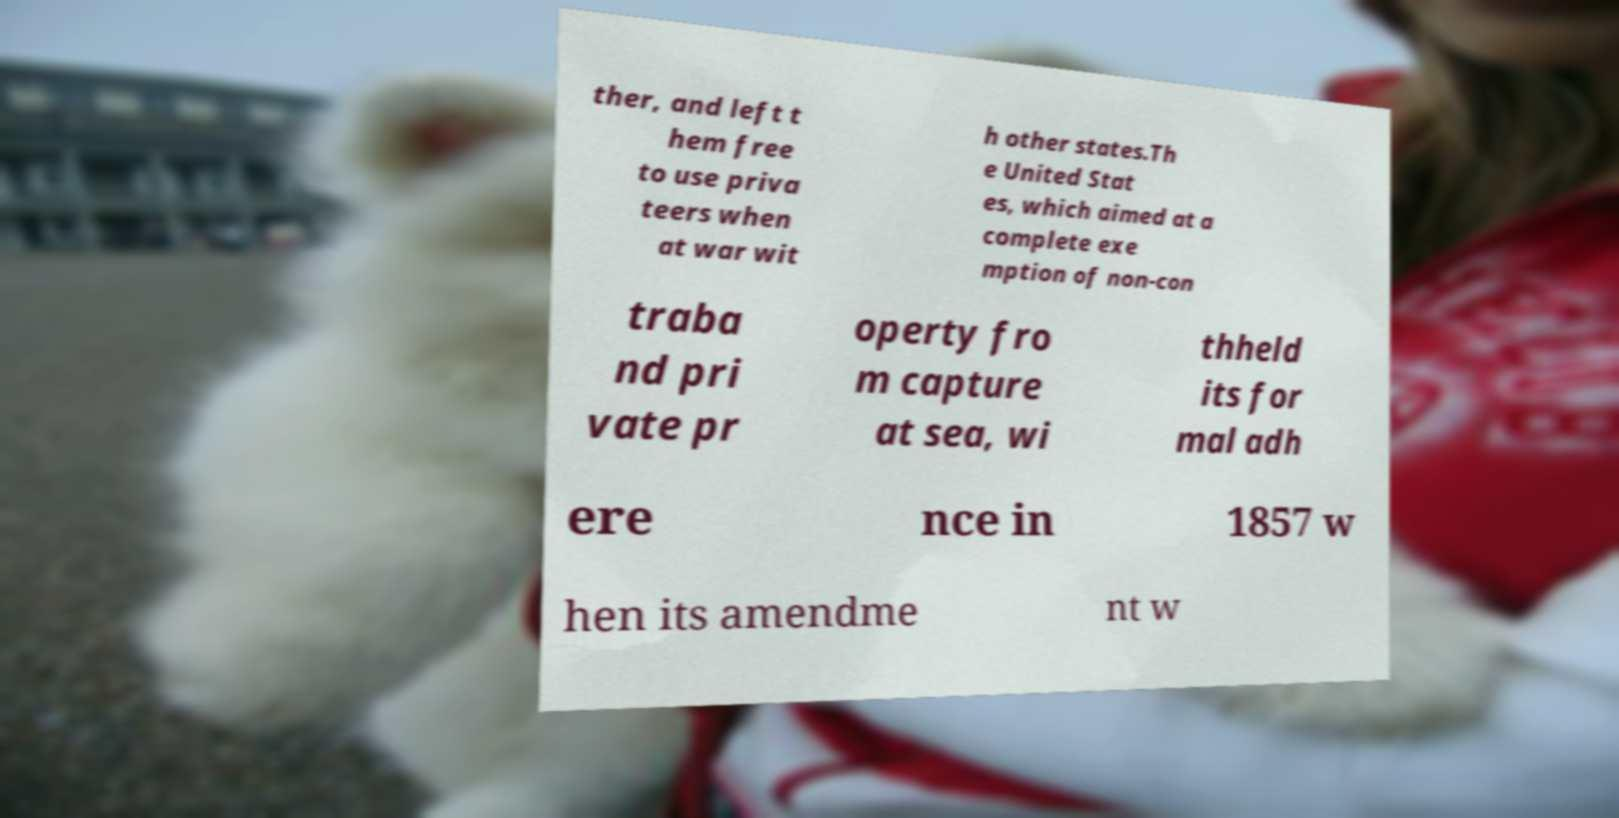Please identify and transcribe the text found in this image. ther, and left t hem free to use priva teers when at war wit h other states.Th e United Stat es, which aimed at a complete exe mption of non-con traba nd pri vate pr operty fro m capture at sea, wi thheld its for mal adh ere nce in 1857 w hen its amendme nt w 